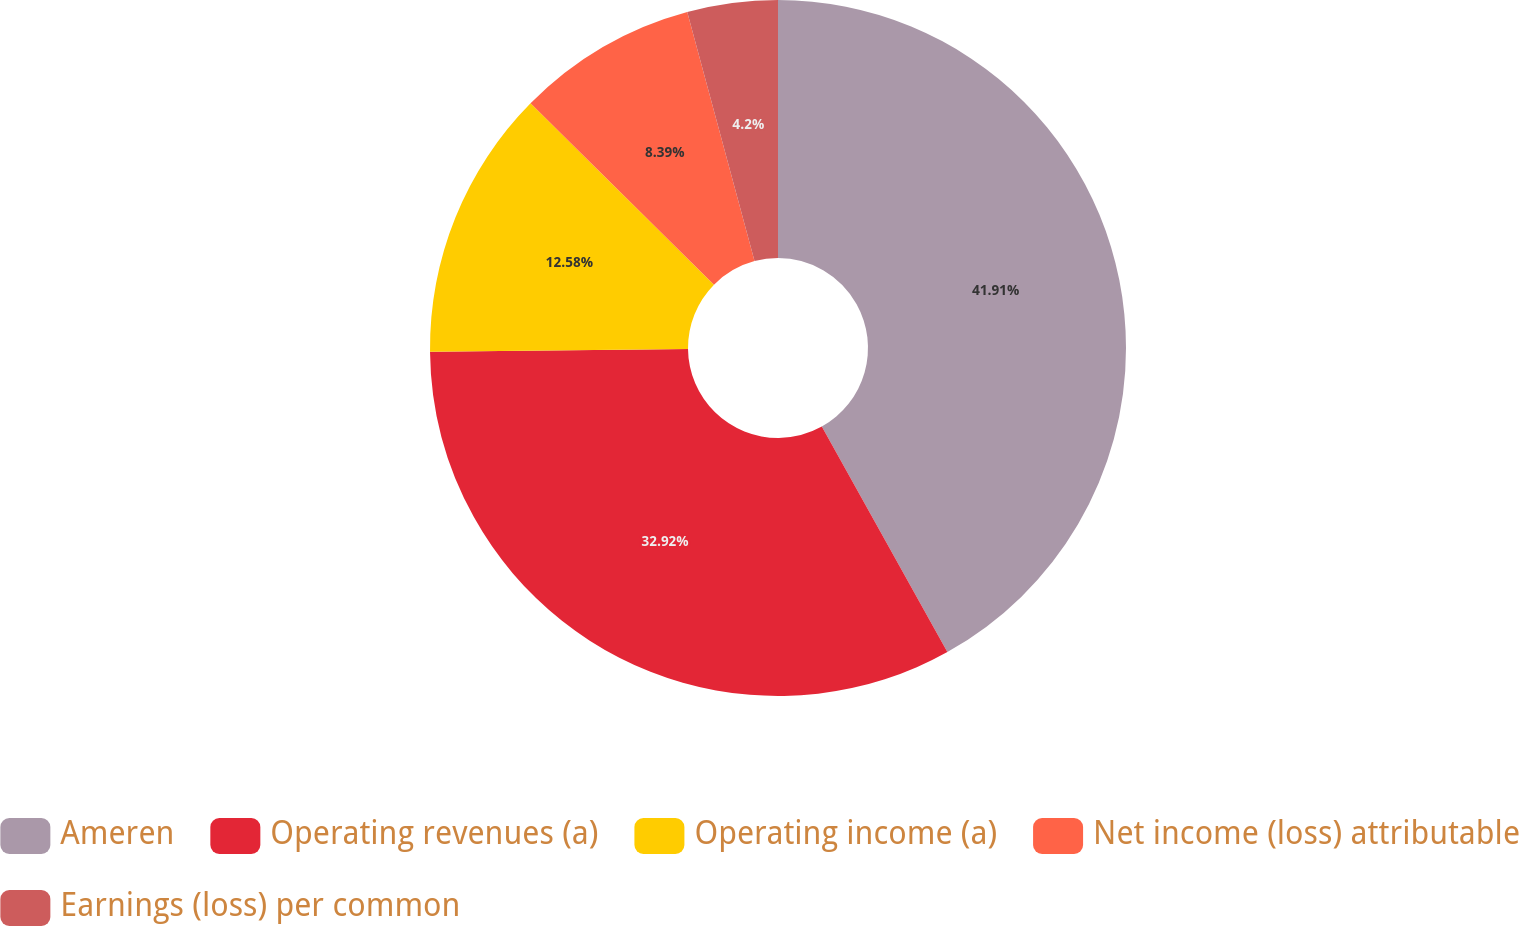<chart> <loc_0><loc_0><loc_500><loc_500><pie_chart><fcel>Ameren<fcel>Operating revenues (a)<fcel>Operating income (a)<fcel>Net income (loss) attributable<fcel>Earnings (loss) per common<nl><fcel>41.91%<fcel>32.92%<fcel>12.58%<fcel>8.39%<fcel>4.2%<nl></chart> 